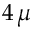Convert formula to latex. <formula><loc_0><loc_0><loc_500><loc_500>4 \, \mu</formula> 